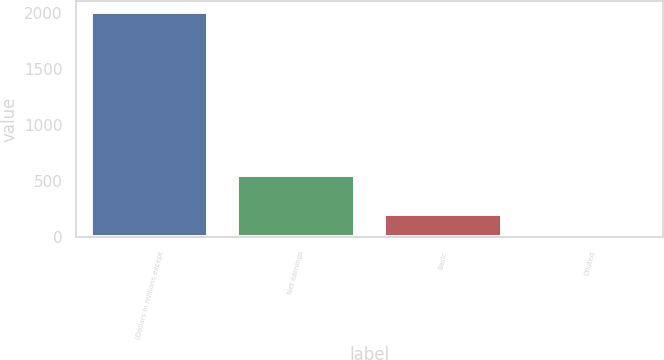Convert chart to OTSL. <chart><loc_0><loc_0><loc_500><loc_500><bar_chart><fcel>(Dollars in millions except<fcel>Net earnings<fcel>Basic<fcel>Diluted<nl><fcel>2005<fcel>557<fcel>206.63<fcel>6.81<nl></chart> 